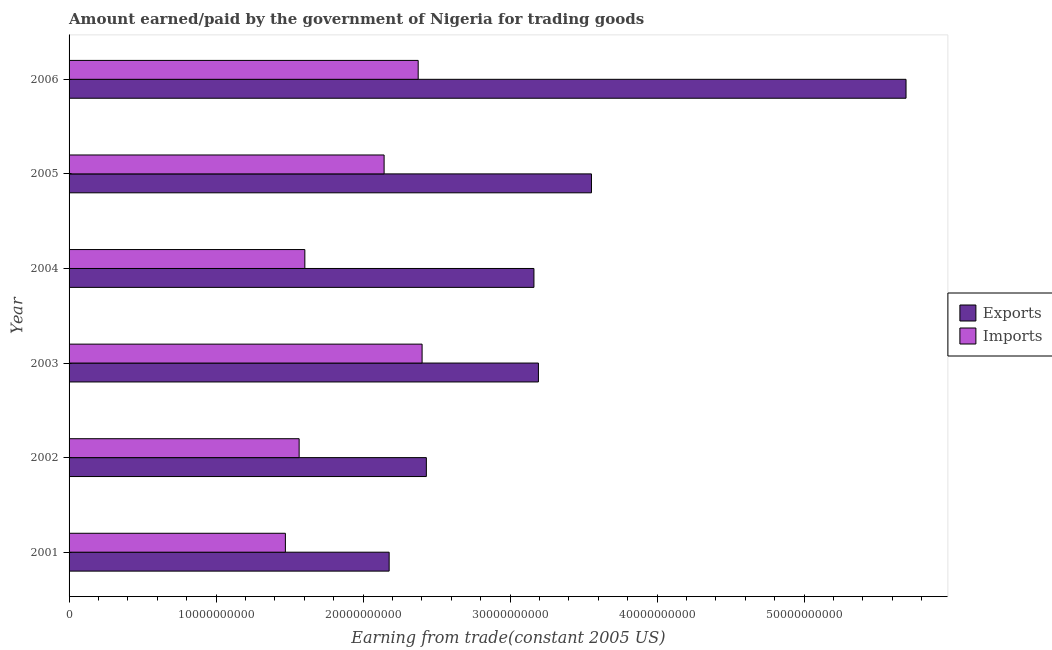How many different coloured bars are there?
Provide a succinct answer. 2. Are the number of bars per tick equal to the number of legend labels?
Your response must be concise. Yes. Are the number of bars on each tick of the Y-axis equal?
Provide a succinct answer. Yes. What is the amount paid for imports in 2001?
Make the answer very short. 1.47e+1. Across all years, what is the maximum amount paid for imports?
Offer a very short reply. 2.40e+1. Across all years, what is the minimum amount paid for imports?
Offer a terse response. 1.47e+1. In which year was the amount paid for imports minimum?
Give a very brief answer. 2001. What is the total amount paid for imports in the graph?
Keep it short and to the point. 1.16e+11. What is the difference between the amount paid for imports in 2001 and that in 2004?
Provide a short and direct response. -1.32e+09. What is the difference between the amount earned from exports in 2002 and the amount paid for imports in 2005?
Ensure brevity in your answer.  2.87e+09. What is the average amount paid for imports per year?
Give a very brief answer. 1.93e+1. In the year 2004, what is the difference between the amount earned from exports and amount paid for imports?
Ensure brevity in your answer.  1.56e+1. What is the ratio of the amount earned from exports in 2004 to that in 2005?
Keep it short and to the point. 0.89. What is the difference between the highest and the second highest amount earned from exports?
Keep it short and to the point. 2.14e+1. What is the difference between the highest and the lowest amount paid for imports?
Make the answer very short. 9.30e+09. Is the sum of the amount earned from exports in 2003 and 2004 greater than the maximum amount paid for imports across all years?
Keep it short and to the point. Yes. What does the 1st bar from the top in 2005 represents?
Your answer should be compact. Imports. What does the 2nd bar from the bottom in 2005 represents?
Your answer should be very brief. Imports. How many bars are there?
Make the answer very short. 12. Are the values on the major ticks of X-axis written in scientific E-notation?
Offer a very short reply. No. Does the graph contain grids?
Provide a short and direct response. No. How are the legend labels stacked?
Your answer should be compact. Vertical. What is the title of the graph?
Your answer should be compact. Amount earned/paid by the government of Nigeria for trading goods. What is the label or title of the X-axis?
Offer a very short reply. Earning from trade(constant 2005 US). What is the label or title of the Y-axis?
Make the answer very short. Year. What is the Earning from trade(constant 2005 US) of Exports in 2001?
Make the answer very short. 2.18e+1. What is the Earning from trade(constant 2005 US) of Imports in 2001?
Your answer should be compact. 1.47e+1. What is the Earning from trade(constant 2005 US) of Exports in 2002?
Provide a short and direct response. 2.43e+1. What is the Earning from trade(constant 2005 US) in Imports in 2002?
Ensure brevity in your answer.  1.56e+1. What is the Earning from trade(constant 2005 US) in Exports in 2003?
Your answer should be compact. 3.19e+1. What is the Earning from trade(constant 2005 US) in Imports in 2003?
Offer a very short reply. 2.40e+1. What is the Earning from trade(constant 2005 US) of Exports in 2004?
Provide a short and direct response. 3.16e+1. What is the Earning from trade(constant 2005 US) in Imports in 2004?
Keep it short and to the point. 1.60e+1. What is the Earning from trade(constant 2005 US) of Exports in 2005?
Keep it short and to the point. 3.55e+1. What is the Earning from trade(constant 2005 US) of Imports in 2005?
Give a very brief answer. 2.14e+1. What is the Earning from trade(constant 2005 US) in Exports in 2006?
Give a very brief answer. 5.69e+1. What is the Earning from trade(constant 2005 US) of Imports in 2006?
Make the answer very short. 2.37e+1. Across all years, what is the maximum Earning from trade(constant 2005 US) in Exports?
Your response must be concise. 5.69e+1. Across all years, what is the maximum Earning from trade(constant 2005 US) of Imports?
Give a very brief answer. 2.40e+1. Across all years, what is the minimum Earning from trade(constant 2005 US) in Exports?
Provide a short and direct response. 2.18e+1. Across all years, what is the minimum Earning from trade(constant 2005 US) of Imports?
Provide a succinct answer. 1.47e+1. What is the total Earning from trade(constant 2005 US) in Exports in the graph?
Your answer should be very brief. 2.02e+11. What is the total Earning from trade(constant 2005 US) of Imports in the graph?
Offer a terse response. 1.16e+11. What is the difference between the Earning from trade(constant 2005 US) of Exports in 2001 and that in 2002?
Your answer should be very brief. -2.53e+09. What is the difference between the Earning from trade(constant 2005 US) of Imports in 2001 and that in 2002?
Your answer should be very brief. -9.35e+08. What is the difference between the Earning from trade(constant 2005 US) of Exports in 2001 and that in 2003?
Your answer should be compact. -1.02e+1. What is the difference between the Earning from trade(constant 2005 US) in Imports in 2001 and that in 2003?
Offer a terse response. -9.30e+09. What is the difference between the Earning from trade(constant 2005 US) of Exports in 2001 and that in 2004?
Provide a succinct answer. -9.85e+09. What is the difference between the Earning from trade(constant 2005 US) of Imports in 2001 and that in 2004?
Provide a succinct answer. -1.32e+09. What is the difference between the Earning from trade(constant 2005 US) in Exports in 2001 and that in 2005?
Your response must be concise. -1.38e+1. What is the difference between the Earning from trade(constant 2005 US) in Imports in 2001 and that in 2005?
Provide a succinct answer. -6.71e+09. What is the difference between the Earning from trade(constant 2005 US) in Exports in 2001 and that in 2006?
Your answer should be very brief. -3.52e+1. What is the difference between the Earning from trade(constant 2005 US) in Imports in 2001 and that in 2006?
Offer a terse response. -9.03e+09. What is the difference between the Earning from trade(constant 2005 US) of Exports in 2002 and that in 2003?
Provide a succinct answer. -7.62e+09. What is the difference between the Earning from trade(constant 2005 US) of Imports in 2002 and that in 2003?
Ensure brevity in your answer.  -8.36e+09. What is the difference between the Earning from trade(constant 2005 US) of Exports in 2002 and that in 2004?
Provide a short and direct response. -7.32e+09. What is the difference between the Earning from trade(constant 2005 US) of Imports in 2002 and that in 2004?
Offer a terse response. -3.88e+08. What is the difference between the Earning from trade(constant 2005 US) of Exports in 2002 and that in 2005?
Make the answer very short. -1.12e+1. What is the difference between the Earning from trade(constant 2005 US) in Imports in 2002 and that in 2005?
Give a very brief answer. -5.78e+09. What is the difference between the Earning from trade(constant 2005 US) in Exports in 2002 and that in 2006?
Offer a terse response. -3.26e+1. What is the difference between the Earning from trade(constant 2005 US) of Imports in 2002 and that in 2006?
Provide a succinct answer. -8.10e+09. What is the difference between the Earning from trade(constant 2005 US) in Exports in 2003 and that in 2004?
Offer a very short reply. 3.05e+08. What is the difference between the Earning from trade(constant 2005 US) of Imports in 2003 and that in 2004?
Provide a short and direct response. 7.98e+09. What is the difference between the Earning from trade(constant 2005 US) of Exports in 2003 and that in 2005?
Provide a short and direct response. -3.61e+09. What is the difference between the Earning from trade(constant 2005 US) of Imports in 2003 and that in 2005?
Your response must be concise. 2.58e+09. What is the difference between the Earning from trade(constant 2005 US) in Exports in 2003 and that in 2006?
Make the answer very short. -2.50e+1. What is the difference between the Earning from trade(constant 2005 US) of Imports in 2003 and that in 2006?
Make the answer very short. 2.66e+08. What is the difference between the Earning from trade(constant 2005 US) in Exports in 2004 and that in 2005?
Your answer should be very brief. -3.91e+09. What is the difference between the Earning from trade(constant 2005 US) of Imports in 2004 and that in 2005?
Provide a succinct answer. -5.39e+09. What is the difference between the Earning from trade(constant 2005 US) of Exports in 2004 and that in 2006?
Your answer should be very brief. -2.53e+1. What is the difference between the Earning from trade(constant 2005 US) in Imports in 2004 and that in 2006?
Your response must be concise. -7.71e+09. What is the difference between the Earning from trade(constant 2005 US) of Exports in 2005 and that in 2006?
Keep it short and to the point. -2.14e+1. What is the difference between the Earning from trade(constant 2005 US) of Imports in 2005 and that in 2006?
Make the answer very short. -2.32e+09. What is the difference between the Earning from trade(constant 2005 US) in Exports in 2001 and the Earning from trade(constant 2005 US) in Imports in 2002?
Give a very brief answer. 6.12e+09. What is the difference between the Earning from trade(constant 2005 US) in Exports in 2001 and the Earning from trade(constant 2005 US) in Imports in 2003?
Provide a succinct answer. -2.24e+09. What is the difference between the Earning from trade(constant 2005 US) in Exports in 2001 and the Earning from trade(constant 2005 US) in Imports in 2004?
Offer a very short reply. 5.73e+09. What is the difference between the Earning from trade(constant 2005 US) in Exports in 2001 and the Earning from trade(constant 2005 US) in Imports in 2005?
Provide a succinct answer. 3.43e+08. What is the difference between the Earning from trade(constant 2005 US) of Exports in 2001 and the Earning from trade(constant 2005 US) of Imports in 2006?
Provide a succinct answer. -1.98e+09. What is the difference between the Earning from trade(constant 2005 US) in Exports in 2002 and the Earning from trade(constant 2005 US) in Imports in 2003?
Offer a terse response. 2.90e+08. What is the difference between the Earning from trade(constant 2005 US) of Exports in 2002 and the Earning from trade(constant 2005 US) of Imports in 2004?
Make the answer very short. 8.27e+09. What is the difference between the Earning from trade(constant 2005 US) of Exports in 2002 and the Earning from trade(constant 2005 US) of Imports in 2005?
Provide a succinct answer. 2.87e+09. What is the difference between the Earning from trade(constant 2005 US) in Exports in 2002 and the Earning from trade(constant 2005 US) in Imports in 2006?
Give a very brief answer. 5.56e+08. What is the difference between the Earning from trade(constant 2005 US) of Exports in 2003 and the Earning from trade(constant 2005 US) of Imports in 2004?
Offer a very short reply. 1.59e+1. What is the difference between the Earning from trade(constant 2005 US) of Exports in 2003 and the Earning from trade(constant 2005 US) of Imports in 2005?
Keep it short and to the point. 1.05e+1. What is the difference between the Earning from trade(constant 2005 US) of Exports in 2003 and the Earning from trade(constant 2005 US) of Imports in 2006?
Keep it short and to the point. 8.18e+09. What is the difference between the Earning from trade(constant 2005 US) of Exports in 2004 and the Earning from trade(constant 2005 US) of Imports in 2005?
Give a very brief answer. 1.02e+1. What is the difference between the Earning from trade(constant 2005 US) in Exports in 2004 and the Earning from trade(constant 2005 US) in Imports in 2006?
Your answer should be compact. 7.87e+09. What is the difference between the Earning from trade(constant 2005 US) of Exports in 2005 and the Earning from trade(constant 2005 US) of Imports in 2006?
Make the answer very short. 1.18e+1. What is the average Earning from trade(constant 2005 US) of Exports per year?
Offer a very short reply. 3.37e+1. What is the average Earning from trade(constant 2005 US) of Imports per year?
Make the answer very short. 1.93e+1. In the year 2001, what is the difference between the Earning from trade(constant 2005 US) in Exports and Earning from trade(constant 2005 US) in Imports?
Your answer should be compact. 7.06e+09. In the year 2002, what is the difference between the Earning from trade(constant 2005 US) of Exports and Earning from trade(constant 2005 US) of Imports?
Offer a terse response. 8.65e+09. In the year 2003, what is the difference between the Earning from trade(constant 2005 US) in Exports and Earning from trade(constant 2005 US) in Imports?
Provide a succinct answer. 7.91e+09. In the year 2004, what is the difference between the Earning from trade(constant 2005 US) in Exports and Earning from trade(constant 2005 US) in Imports?
Make the answer very short. 1.56e+1. In the year 2005, what is the difference between the Earning from trade(constant 2005 US) of Exports and Earning from trade(constant 2005 US) of Imports?
Keep it short and to the point. 1.41e+1. In the year 2006, what is the difference between the Earning from trade(constant 2005 US) in Exports and Earning from trade(constant 2005 US) in Imports?
Your response must be concise. 3.32e+1. What is the ratio of the Earning from trade(constant 2005 US) in Exports in 2001 to that in 2002?
Ensure brevity in your answer.  0.9. What is the ratio of the Earning from trade(constant 2005 US) of Imports in 2001 to that in 2002?
Offer a terse response. 0.94. What is the ratio of the Earning from trade(constant 2005 US) of Exports in 2001 to that in 2003?
Offer a very short reply. 0.68. What is the ratio of the Earning from trade(constant 2005 US) of Imports in 2001 to that in 2003?
Your response must be concise. 0.61. What is the ratio of the Earning from trade(constant 2005 US) of Exports in 2001 to that in 2004?
Provide a short and direct response. 0.69. What is the ratio of the Earning from trade(constant 2005 US) in Imports in 2001 to that in 2004?
Make the answer very short. 0.92. What is the ratio of the Earning from trade(constant 2005 US) of Exports in 2001 to that in 2005?
Your answer should be compact. 0.61. What is the ratio of the Earning from trade(constant 2005 US) in Imports in 2001 to that in 2005?
Make the answer very short. 0.69. What is the ratio of the Earning from trade(constant 2005 US) of Exports in 2001 to that in 2006?
Offer a terse response. 0.38. What is the ratio of the Earning from trade(constant 2005 US) of Imports in 2001 to that in 2006?
Provide a short and direct response. 0.62. What is the ratio of the Earning from trade(constant 2005 US) of Exports in 2002 to that in 2003?
Provide a succinct answer. 0.76. What is the ratio of the Earning from trade(constant 2005 US) in Imports in 2002 to that in 2003?
Offer a very short reply. 0.65. What is the ratio of the Earning from trade(constant 2005 US) of Exports in 2002 to that in 2004?
Your answer should be compact. 0.77. What is the ratio of the Earning from trade(constant 2005 US) in Imports in 2002 to that in 2004?
Your answer should be very brief. 0.98. What is the ratio of the Earning from trade(constant 2005 US) of Exports in 2002 to that in 2005?
Offer a very short reply. 0.68. What is the ratio of the Earning from trade(constant 2005 US) in Imports in 2002 to that in 2005?
Ensure brevity in your answer.  0.73. What is the ratio of the Earning from trade(constant 2005 US) in Exports in 2002 to that in 2006?
Your answer should be compact. 0.43. What is the ratio of the Earning from trade(constant 2005 US) of Imports in 2002 to that in 2006?
Make the answer very short. 0.66. What is the ratio of the Earning from trade(constant 2005 US) in Exports in 2003 to that in 2004?
Your answer should be compact. 1.01. What is the ratio of the Earning from trade(constant 2005 US) of Imports in 2003 to that in 2004?
Give a very brief answer. 1.5. What is the ratio of the Earning from trade(constant 2005 US) of Exports in 2003 to that in 2005?
Offer a very short reply. 0.9. What is the ratio of the Earning from trade(constant 2005 US) in Imports in 2003 to that in 2005?
Make the answer very short. 1.12. What is the ratio of the Earning from trade(constant 2005 US) in Exports in 2003 to that in 2006?
Give a very brief answer. 0.56. What is the ratio of the Earning from trade(constant 2005 US) in Imports in 2003 to that in 2006?
Provide a short and direct response. 1.01. What is the ratio of the Earning from trade(constant 2005 US) in Exports in 2004 to that in 2005?
Offer a very short reply. 0.89. What is the ratio of the Earning from trade(constant 2005 US) in Imports in 2004 to that in 2005?
Provide a succinct answer. 0.75. What is the ratio of the Earning from trade(constant 2005 US) in Exports in 2004 to that in 2006?
Ensure brevity in your answer.  0.56. What is the ratio of the Earning from trade(constant 2005 US) of Imports in 2004 to that in 2006?
Make the answer very short. 0.68. What is the ratio of the Earning from trade(constant 2005 US) of Exports in 2005 to that in 2006?
Give a very brief answer. 0.62. What is the ratio of the Earning from trade(constant 2005 US) in Imports in 2005 to that in 2006?
Provide a short and direct response. 0.9. What is the difference between the highest and the second highest Earning from trade(constant 2005 US) of Exports?
Your answer should be very brief. 2.14e+1. What is the difference between the highest and the second highest Earning from trade(constant 2005 US) in Imports?
Offer a very short reply. 2.66e+08. What is the difference between the highest and the lowest Earning from trade(constant 2005 US) of Exports?
Make the answer very short. 3.52e+1. What is the difference between the highest and the lowest Earning from trade(constant 2005 US) in Imports?
Give a very brief answer. 9.30e+09. 